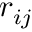<formula> <loc_0><loc_0><loc_500><loc_500>r _ { i j }</formula> 